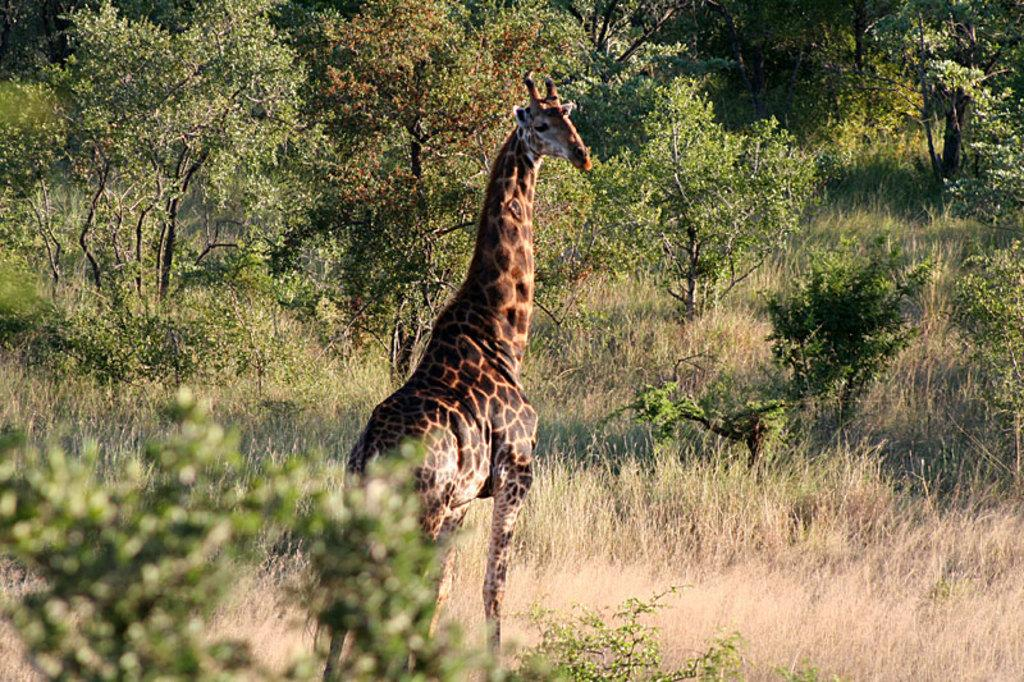What type of animal is present in the image? There is a giraffe in the image. What type of vegetation can be seen in the image? There is grass, plants, and trees in the image. What type of trick does the giraffe perform in the image? There is no trick being performed by the giraffe in the image; it is simply standing there. What type of jeans is the giraffe wearing in the image? Giraffes do not wear jeans, as they are animals and not humans. 